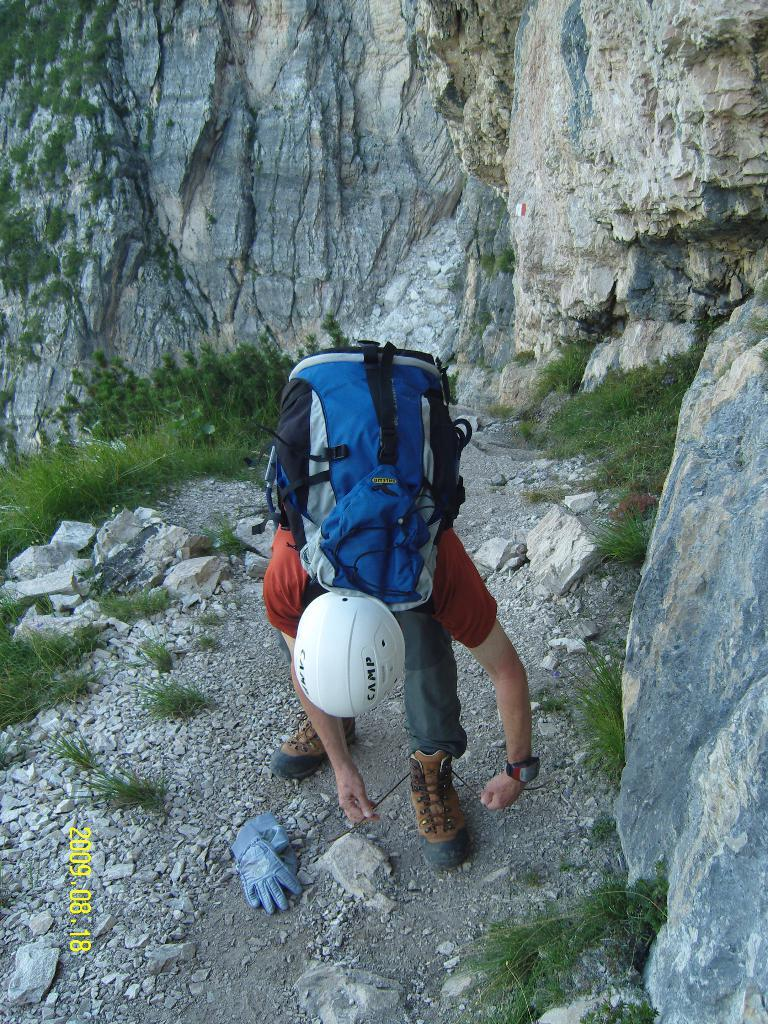What is the person in the image doing? The person is tying their shoelace. What is the person wearing on their back? The person is wearing a backpack. What can be seen in the background of the image? There are plants and rocks visible in the background. What rate is the person achieving in the image? There is no indication of any rate in the image. The person is simply tying their shoelace. 